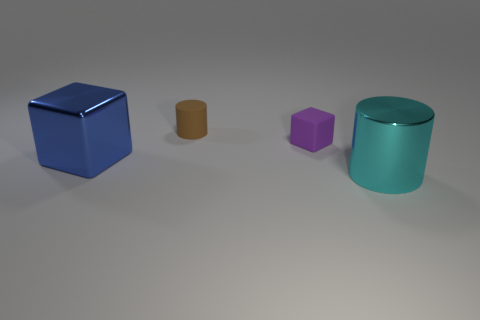The big object that is on the left side of the large object that is to the right of the tiny cylinder is made of what material?
Your answer should be very brief. Metal. Is there a purple shiny ball that has the same size as the metallic cylinder?
Offer a terse response. No. How many things are cylinders that are on the right side of the tiny purple rubber thing or things that are on the left side of the big cyan metallic object?
Provide a short and direct response. 4. There is a block that is right of the big blue block; is its size the same as the rubber cylinder behind the cyan shiny object?
Your response must be concise. Yes. Are there any objects that are on the left side of the small thing to the left of the tiny matte cube?
Your answer should be very brief. Yes. How many tiny cylinders are to the left of the tiny purple object?
Your answer should be compact. 1. How many other things are there of the same color as the small block?
Your answer should be compact. 0. Are there fewer big cyan shiny objects that are to the right of the big cyan metallic cylinder than metallic things that are in front of the large blue shiny cube?
Keep it short and to the point. Yes. What number of things are matte objects that are on the left side of the small block or large cubes?
Keep it short and to the point. 2. Is the size of the brown matte thing the same as the metal thing to the left of the cyan shiny cylinder?
Give a very brief answer. No. 